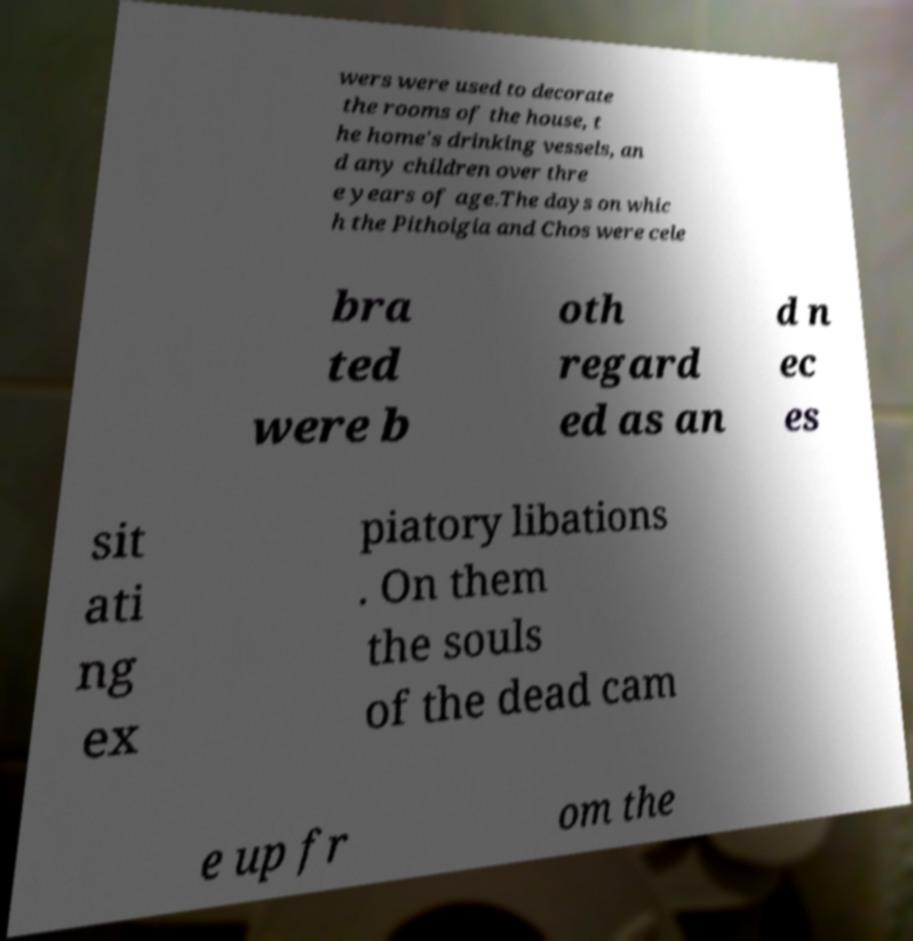Can you accurately transcribe the text from the provided image for me? wers were used to decorate the rooms of the house, t he home's drinking vessels, an d any children over thre e years of age.The days on whic h the Pithoigia and Chos were cele bra ted were b oth regard ed as an d n ec es sit ati ng ex piatory libations . On them the souls of the dead cam e up fr om the 